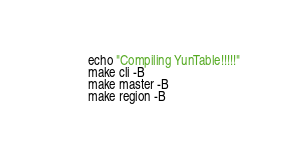<code> <loc_0><loc_0><loc_500><loc_500><_Bash_>echo "Compiling YunTable!!!!!"
make cli -B
make master -B
make region -B
</code> 